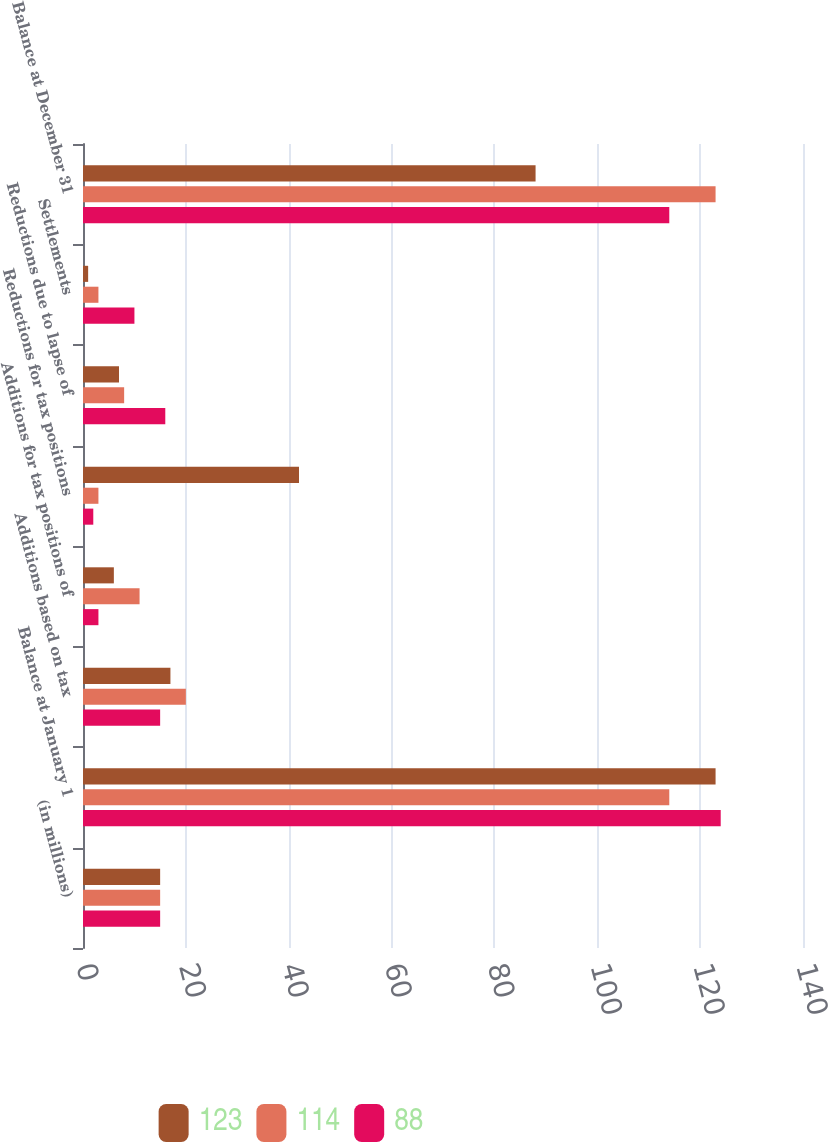Convert chart. <chart><loc_0><loc_0><loc_500><loc_500><stacked_bar_chart><ecel><fcel>(in millions)<fcel>Balance at January 1<fcel>Additions based on tax<fcel>Additions for tax positions of<fcel>Reductions for tax positions<fcel>Reductions due to lapse of<fcel>Settlements<fcel>Balance at December 31<nl><fcel>123<fcel>15<fcel>123<fcel>17<fcel>6<fcel>42<fcel>7<fcel>1<fcel>88<nl><fcel>114<fcel>15<fcel>114<fcel>20<fcel>11<fcel>3<fcel>8<fcel>3<fcel>123<nl><fcel>88<fcel>15<fcel>124<fcel>15<fcel>3<fcel>2<fcel>16<fcel>10<fcel>114<nl></chart> 